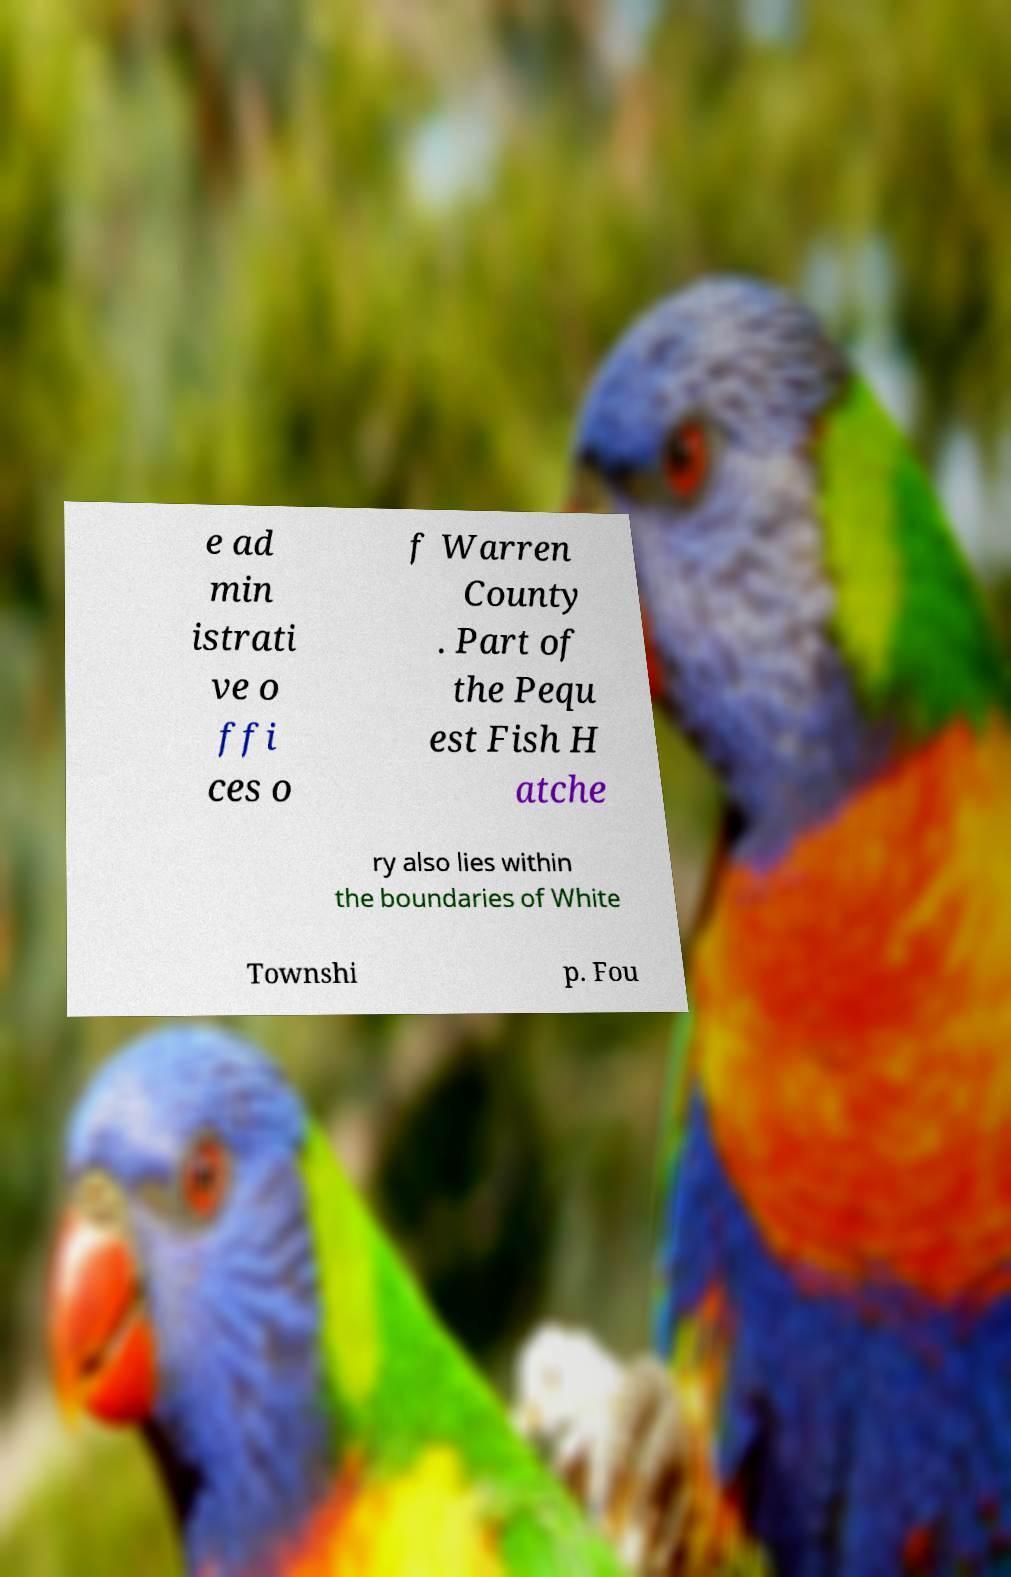There's text embedded in this image that I need extracted. Can you transcribe it verbatim? e ad min istrati ve o ffi ces o f Warren County . Part of the Pequ est Fish H atche ry also lies within the boundaries of White Townshi p. Fou 